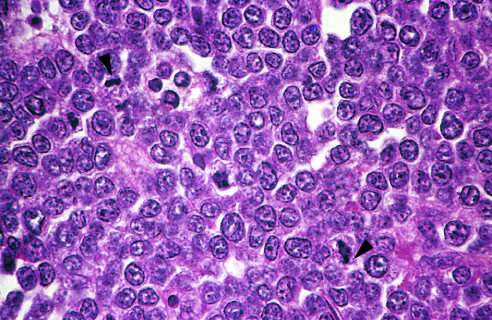whose nuclei are fairly uniform, giving a monotonous appearance?
Answer the question using a single word or phrase. The tumor cells 